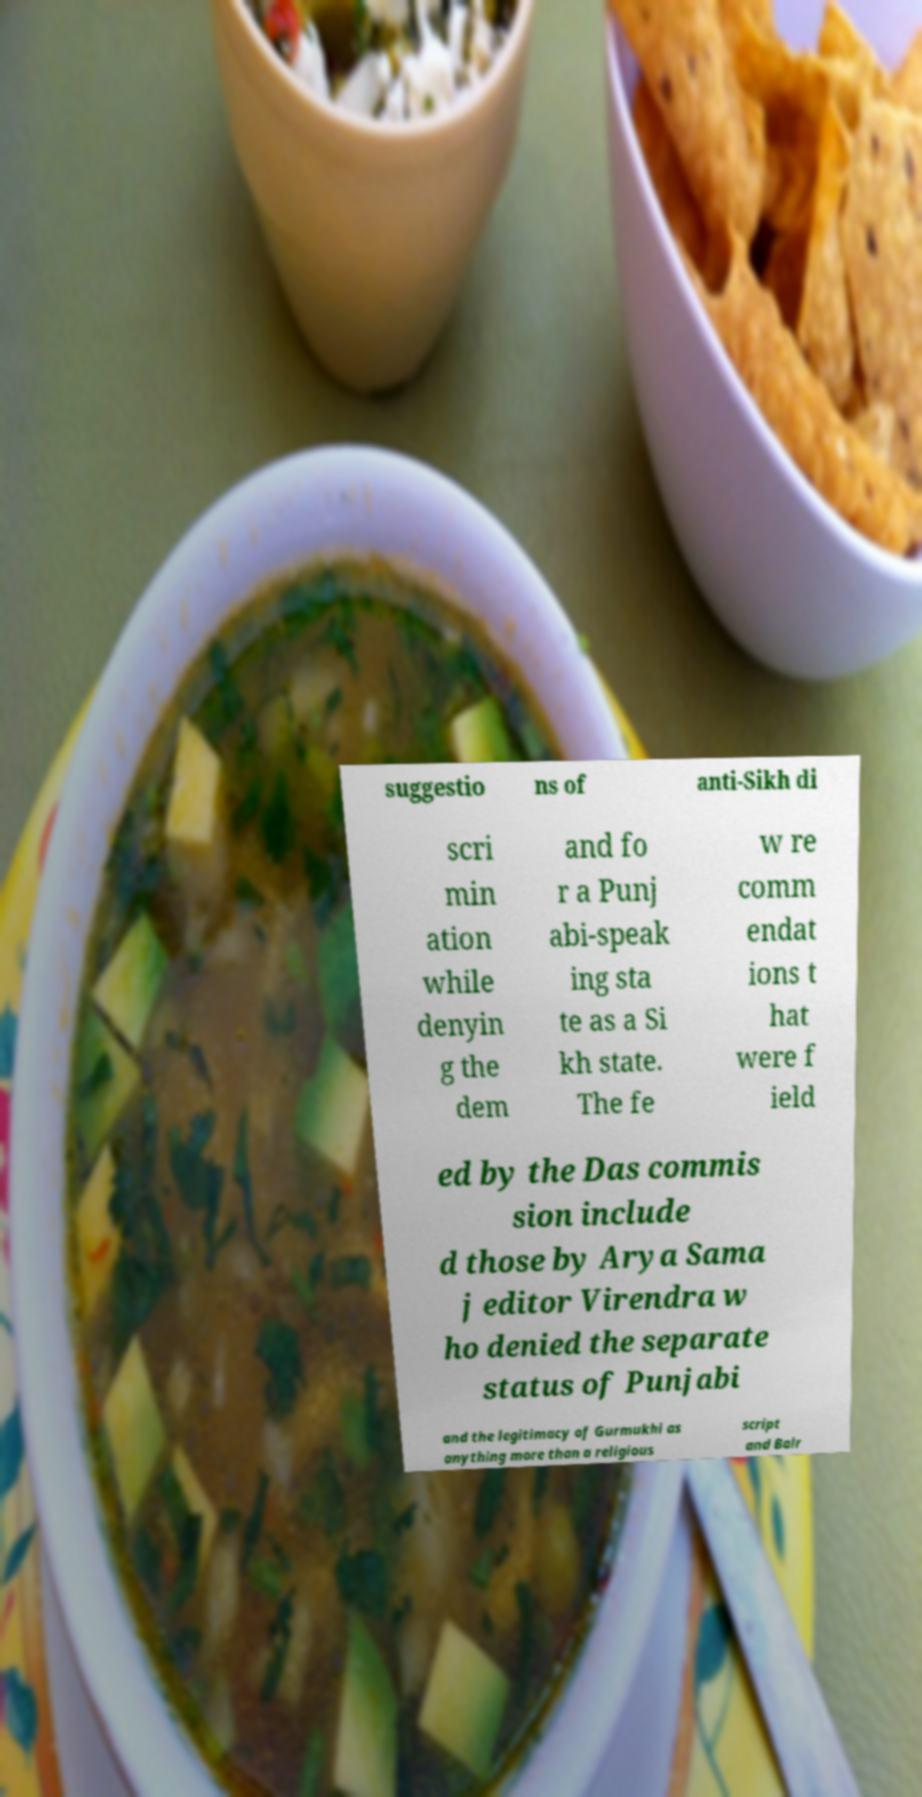I need the written content from this picture converted into text. Can you do that? suggestio ns of anti-Sikh di scri min ation while denyin g the dem and fo r a Punj abi-speak ing sta te as a Si kh state. The fe w re comm endat ions t hat were f ield ed by the Das commis sion include d those by Arya Sama j editor Virendra w ho denied the separate status of Punjabi and the legitimacy of Gurmukhi as anything more than a religious script and Balr 